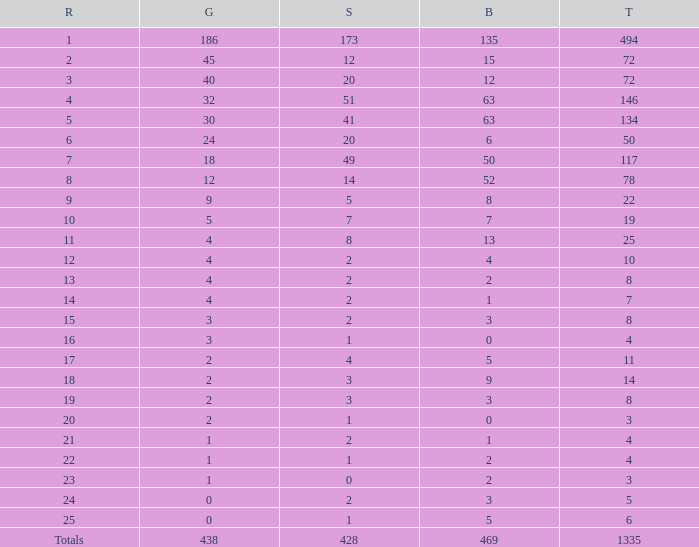What is the total amount of gold medals when there were more than 20 silvers and there were 135 bronze medals? 1.0. 